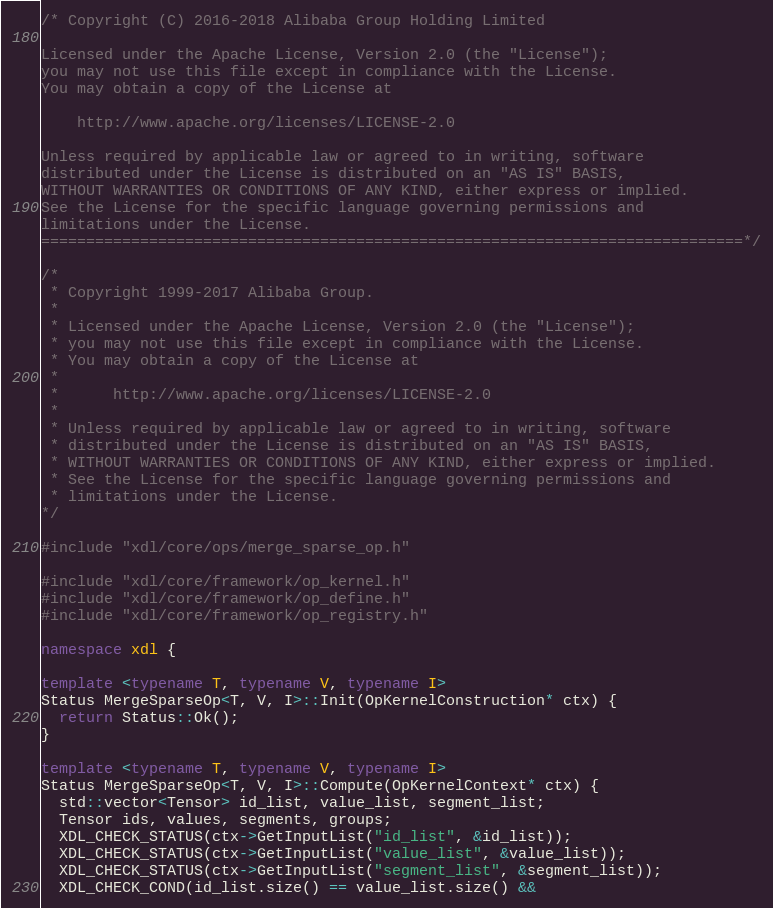<code> <loc_0><loc_0><loc_500><loc_500><_C++_>/* Copyright (C) 2016-2018 Alibaba Group Holding Limited

Licensed under the Apache License, Version 2.0 (the "License");
you may not use this file except in compliance with the License.
You may obtain a copy of the License at

    http://www.apache.org/licenses/LICENSE-2.0

Unless required by applicable law or agreed to in writing, software
distributed under the License is distributed on an "AS IS" BASIS,
WITHOUT WARRANTIES OR CONDITIONS OF ANY KIND, either express or implied.
See the License for the specific language governing permissions and
limitations under the License.
==============================================================================*/

/*
 * Copyright 1999-2017 Alibaba Group.
 *
 * Licensed under the Apache License, Version 2.0 (the "License");
 * you may not use this file except in compliance with the License.
 * You may obtain a copy of the License at
 *
 *      http://www.apache.org/licenses/LICENSE-2.0
 *
 * Unless required by applicable law or agreed to in writing, software
 * distributed under the License is distributed on an "AS IS" BASIS,
 * WITHOUT WARRANTIES OR CONDITIONS OF ANY KIND, either express or implied.
 * See the License for the specific language governing permissions and
 * limitations under the License.
*/

#include "xdl/core/ops/merge_sparse_op.h"

#include "xdl/core/framework/op_kernel.h"
#include "xdl/core/framework/op_define.h"
#include "xdl/core/framework/op_registry.h"

namespace xdl {

template <typename T, typename V, typename I>
Status MergeSparseOp<T, V, I>::Init(OpKernelConstruction* ctx) {
  return Status::Ok();
}

template <typename T, typename V, typename I>
Status MergeSparseOp<T, V, I>::Compute(OpKernelContext* ctx) {
  std::vector<Tensor> id_list, value_list, segment_list;
  Tensor ids, values, segments, groups;
  XDL_CHECK_STATUS(ctx->GetInputList("id_list", &id_list));
  XDL_CHECK_STATUS(ctx->GetInputList("value_list", &value_list));
  XDL_CHECK_STATUS(ctx->GetInputList("segment_list", &segment_list));
  XDL_CHECK_COND(id_list.size() == value_list.size() &&</code> 